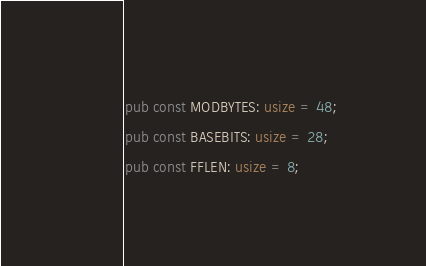Convert code to text. <code><loc_0><loc_0><loc_500><loc_500><_Rust_>pub const MODBYTES: usize = 48;
pub const BASEBITS: usize = 28;
pub const FFLEN: usize = 8;</code> 